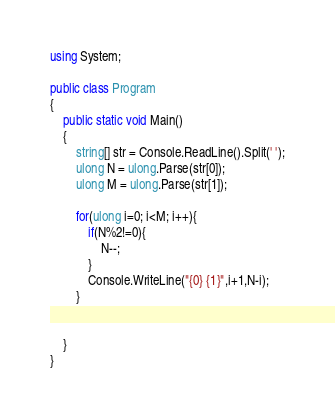<code> <loc_0><loc_0><loc_500><loc_500><_C#_>using System;
					
public class Program
{
	public static void Main()
	{
		string[] str = Console.ReadLine().Split(' ');
		ulong N = ulong.Parse(str[0]); 
      	ulong M = ulong.Parse(str[1]); 
		
		for(ulong i=0; i<M; i++){
			if(N%2!=0){
				N--;
			}
			Console.WriteLine("{0} {1}",i+1,N-i);
		}
		
		
	}
}
</code> 